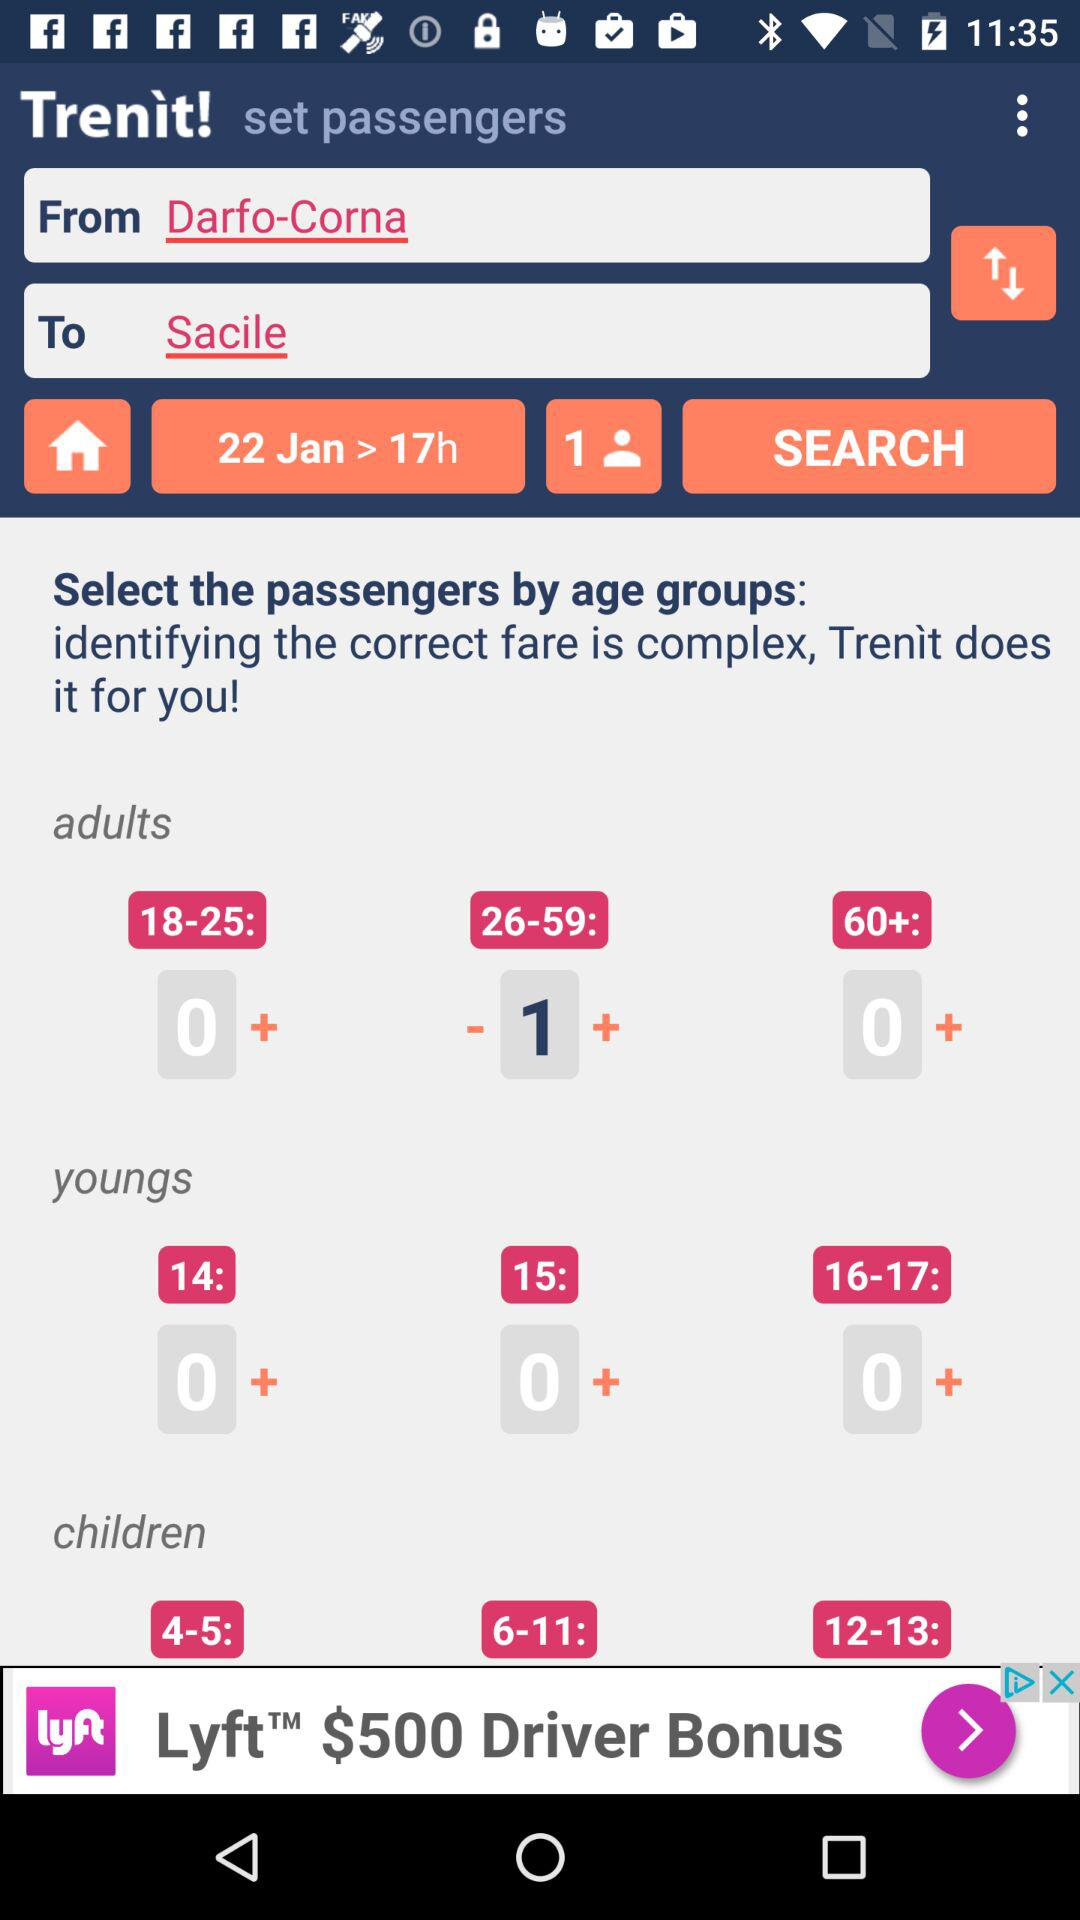What is the given date of the journey? The given date of the journey is January 22. 